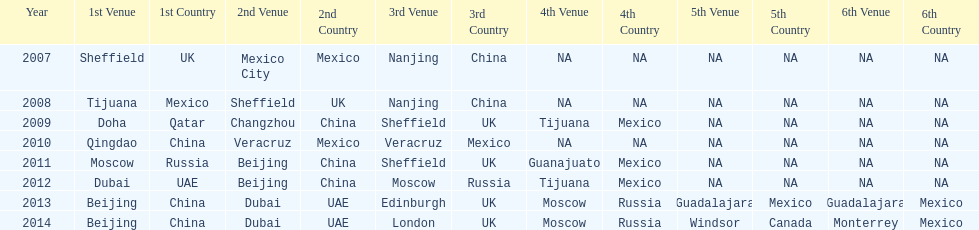Which year had more venues, 2007 or 2012? 2012. 